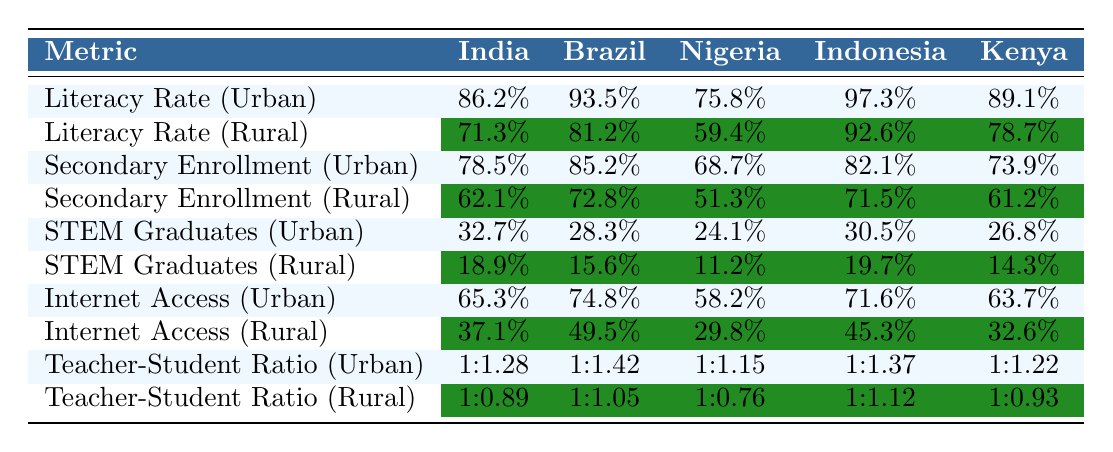What is the urban literacy rate in Kenya? The table indicates the urban literacy rate for Kenya is listed distinctly. Referring to the respective column, the urban literacy rate for Kenya is 89.1%.
Answer: 89.1% What is the difference between urban and rural literacy rates in Nigeria? To find the difference, subtract the rural literacy rate from the urban literacy rate for Nigeria. Urban literacy rate is 75.8%, and rural is 59.4%. Therefore, 75.8% - 59.4% = 16.4%.
Answer: 16.4% Which country has the highest urban secondary enrollment? By examining the urban secondary enrollment column, Brazil is identified to have the highest value at 85.2%.
Answer: Brazil Are urban STEM graduates in India higher than urban STEM graduates in Kenya? Yes, comparing the urban STEM graduates percentage of India (32.7%) with Kenya (26.8%), India has a higher percentage.
Answer: Yes What percentage of rural students in Nigeria have access to the internet? The rural internet access percentage for Nigeria is explicitly stated in the table as 29.8%.
Answer: 29.8% What is the average urban literacy rate across all five countries? To calculate the average, sum the urban literacy rates: (86.2 + 93.5 + 75.8 + 97.3 + 89.1) = 441.9. Then divide by the number of countries (5), resulting in an average urban literacy rate of 88.38%.
Answer: 88.38% Is the teacher-student ratio in rural India better than in urban Nigeria? The teacher-student ratio in rural India is 1:0.89 and in urban Nigeria it is 1:1.15. Lower ratios are better, thus rural India (0.89) has a better ratio than urban Nigeria (1.15).
Answer: Yes What is the percentage increase in urban secondary enrollment from rural secondary enrollment in Kenya? The urban secondary enrollment in Kenya is 73.9% and the rural is 61.2%. The increase is calculated as (73.9% - 61.2%) / 61.2% * 100%. This results in approximately 20.8% increase in percentage points.
Answer: 20.8% What is the average teacher-student ratio for urban areas across all countries? To find the average urban teacher-student ratio, add them up: (1.28 + 1.42 + 1.15 + 1.37 + 1.22) = 6.44. Dividing by 5 gives an average urban teacher-student ratio of 1:1.288, or approximately 1:1.29.
Answer: 1:1.29 Do rural students in Indonesia have higher secondary enrollment than rural students in Nigeria? Yes, by checking the secondary enrollment figures, rural Indonesia is at 71.5%, which is higher than rural Nigeria at 51.3%.
Answer: Yes 